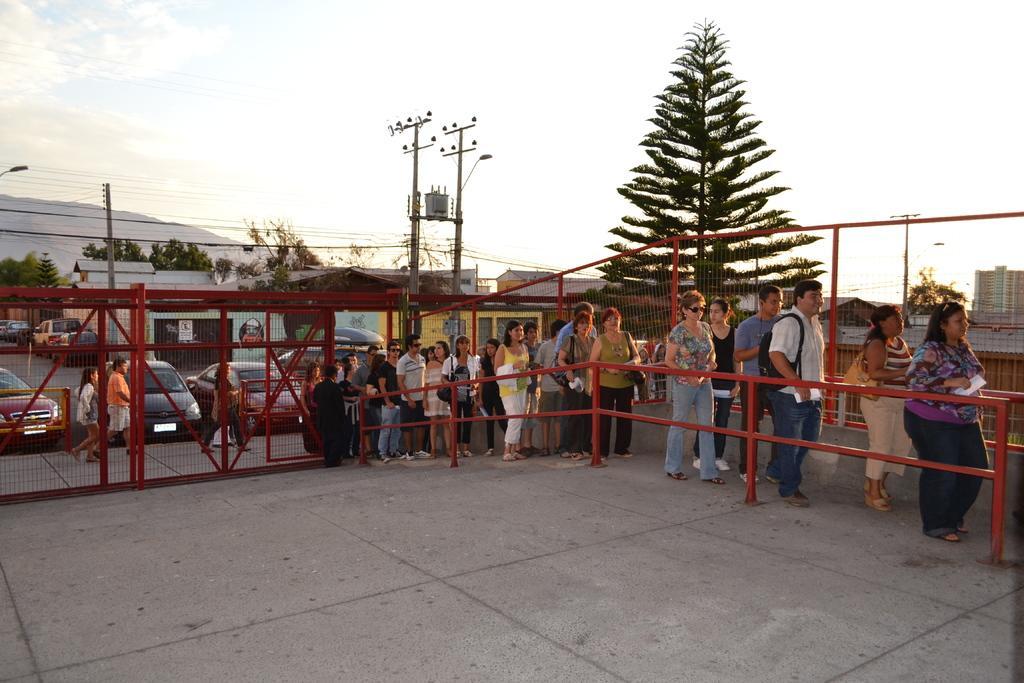Can you describe this image briefly? In this image we can see some persons standing in a row in between fencing which is in red color and in the background of the image there are some cars parked, there are some houses, trees and top of the image there is clear sky. 